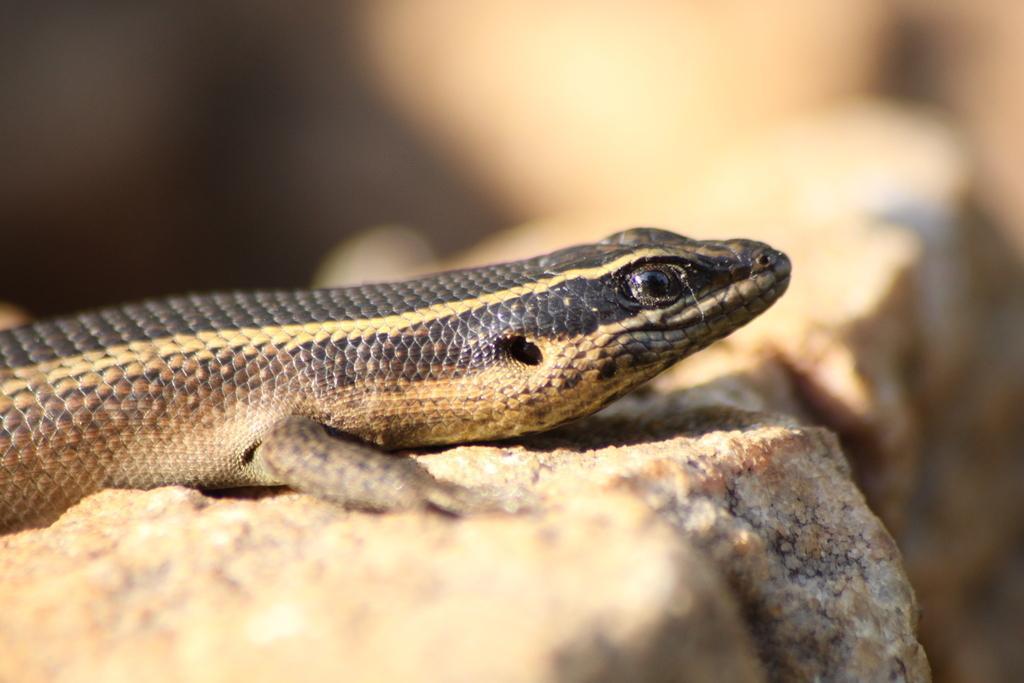Could you give a brief overview of what you see in this image? This picture is clicked outside. In the center there is a reptile on an object. The background of the image is blurry. 